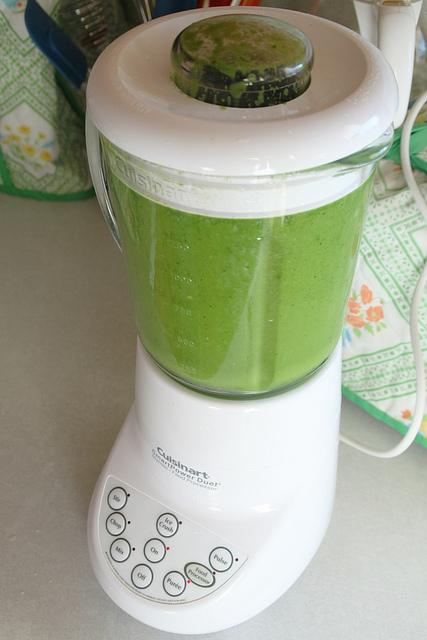Is this a vegetarian dish?
Answer briefly. Yes. What color is the smoothie?
Answer briefly. Green. What is plugged into the wall?
Keep it brief. Blender. Is this in a restaurant or home kitchen?
Short answer required. Home. What is the object shown in the picture?
Concise answer only. Blender. 